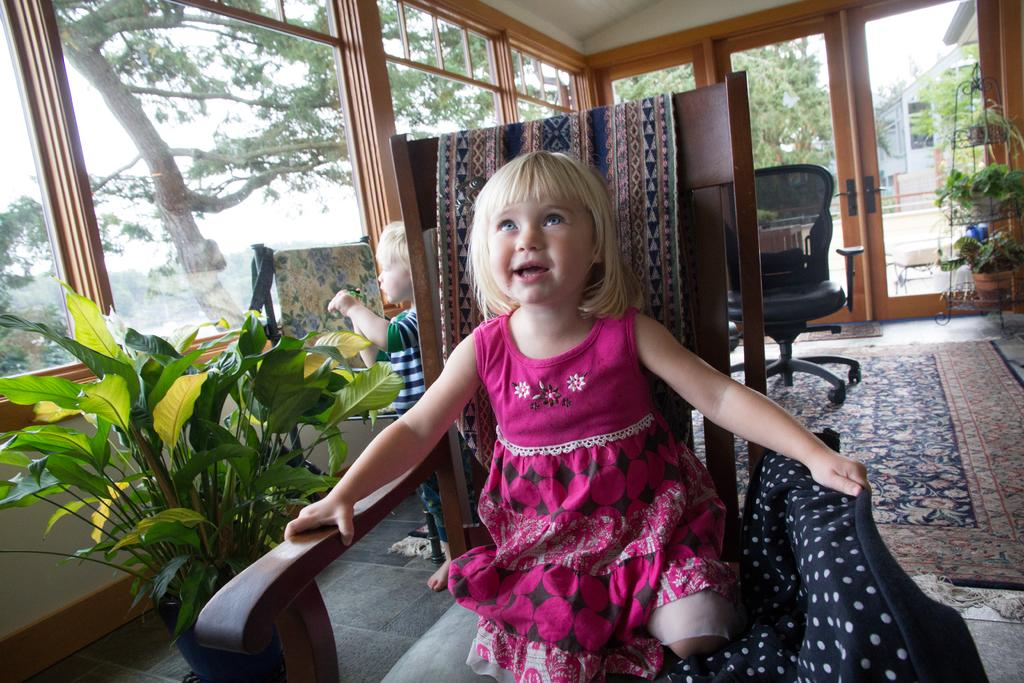How many people are in the image? There is a girl and a boy in the image. What is the girl wearing? The girl is wearing a pink dress. What is the girl doing in the image? The girl is sitting on a chair. What other objects can be seen in the image? There is a plant, a window, and a chair in the image. What type of locket is the girl holding in the image? There is no locket present in the image. What action is the boy performing in the image? The provided facts do not mention any specific action performed by the boy in the image. 